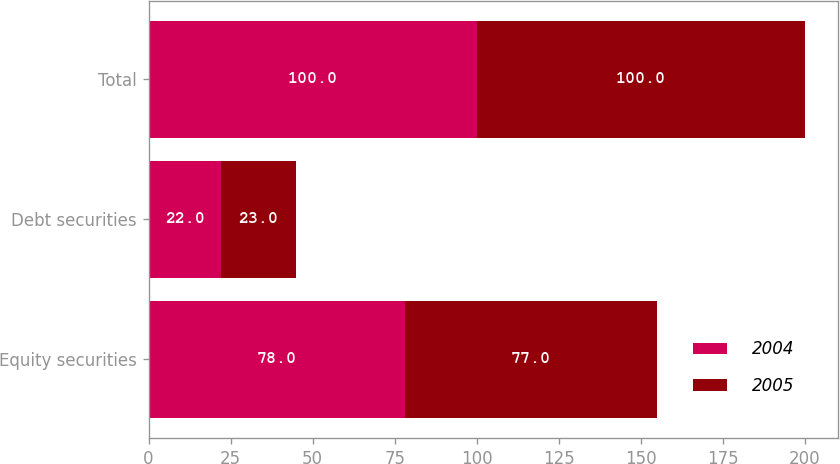Convert chart. <chart><loc_0><loc_0><loc_500><loc_500><stacked_bar_chart><ecel><fcel>Equity securities<fcel>Debt securities<fcel>Total<nl><fcel>2004<fcel>78<fcel>22<fcel>100<nl><fcel>2005<fcel>77<fcel>23<fcel>100<nl></chart> 